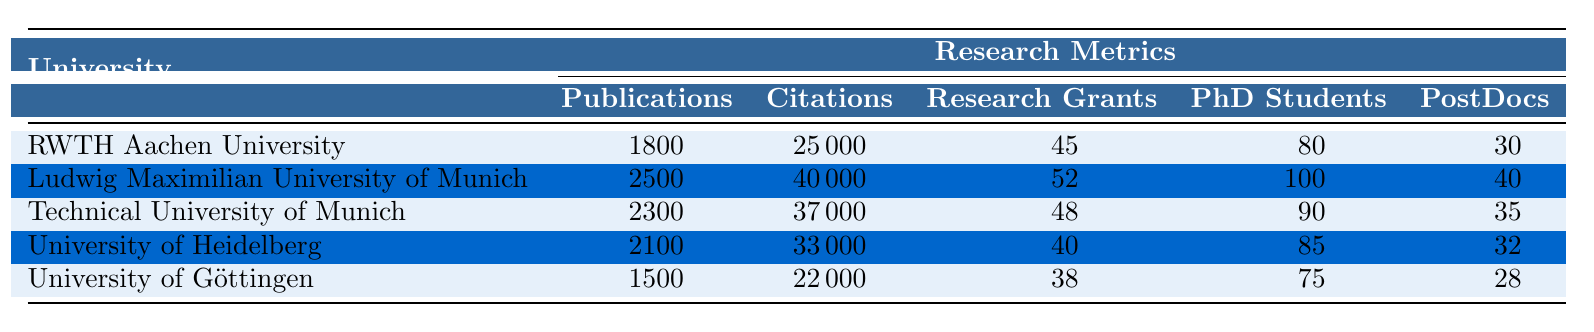What is the university with the highest number of publications? By examining the "Publications" column, we see that Ludwig Maximilian University of Munich has the highest value at 2500.
Answer: Ludwig Maximilian University of Munich How many PhD students does RWTH Aachen University have? The "PhD Students" column specifies that RWTH Aachen University has 80 PhD students.
Answer: 80 What is the average number of citations across all listed universities? The total number of citations is (25000 + 40000 + 37000 + 33000 + 22000) = 159000. There are 5 universities, so the average is 159000 / 5 = 31800.
Answer: 31800 Is it true that the University of Göttingen has more postdocs than the University of Heidelberg? According to the "PostDocs" column, the University of Göttingen has 28 postdocs, while the University of Heidelberg has 32. Thus, the statement is false.
Answer: No What is the total number of research grants for Technical University of Munich and University of Heidelberg combined? Adding the research grants together, we find that Technical University of Munich has 48 and University of Heidelberg has 40. Thus, the total is 48 + 40 = 88.
Answer: 88 Which university has the lowest number of citations? By looking at the "Citations" column, we find that the University of Göttingen has the lowest count with 22000.
Answer: University of Göttingen How many more PhD students does Ludwig Maximilian University of Munich have compared to RWTH Aachen University? Ludwig Maximilian University of Munich has 100 PhD students, while RWTH Aachen University has 80. Therefore, the difference is 100 - 80 = 20.
Answer: 20 What is the sum of publications and citations for the University of Heidelberg? The University of Heidelberg has 2100 publications and 33000 citations. Adding these together gives 2100 + 33000 = 35100.
Answer: 35100 Which university has more research grants: RWTH Aachen University or University of Göttingen? RWTH Aachen University has 45 research grants, whereas University of Göttingen has 38. Since 45 > 38, RWTH Aachen University has more grants.
Answer: RWTH Aachen University 